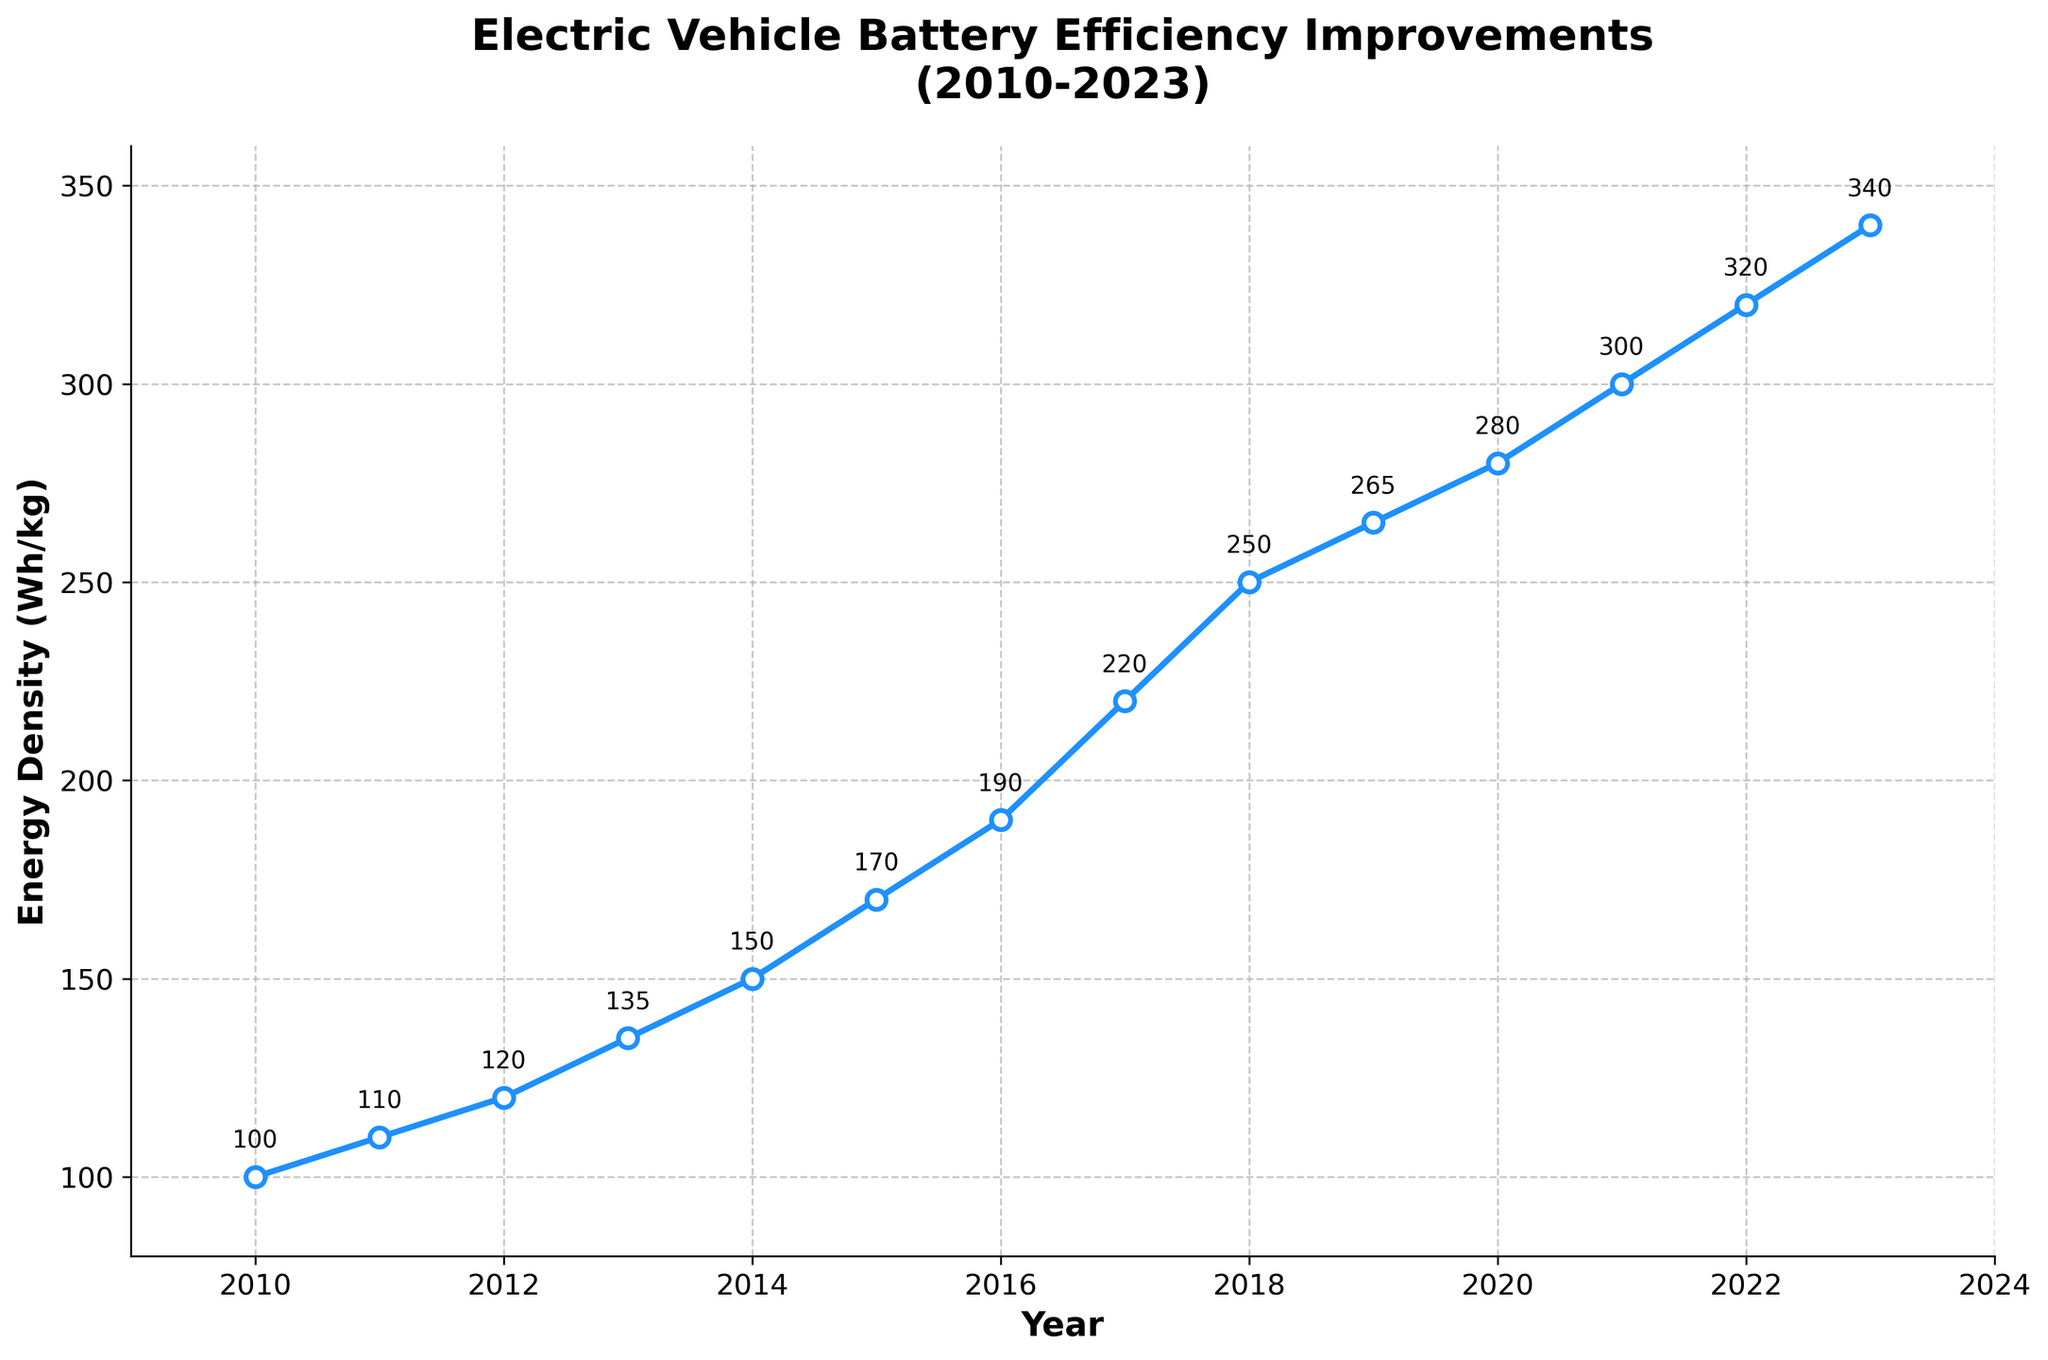What's the energy density in 2015? The figure annotates each point with its corresponding energy density value. For 2015, the annotated value is 170 Wh/kg
Answer: 170 Wh/kg Between which two consecutive years did the energy density see the largest increase? To determine this, look at the differences between consecutive years: 2010-2011 (10), 2011-2012 (10), 2012-2013 (15), 2013-2014 (15), 2014-2015 (20), 2015-2016 (20), 2016-2017 (30), 2017-2018 (30), 2018-2019 (15), 2019-2020 (15), 2020-2021 (20), 2021-2022 (20), 2022-2023 (20). The largest increase, 30, occurs between 2016-2017 and 2017-2018
Answer: 2016-2017 and 2017-2018 What is the average energy density increase per year from 2010 to 2023? First, find the total increase in energy density from 2010 to 2023, which is 340 - 100 = 240 Wh/kg. Then, divide this by the number of years (2023-2010) which is 13. So, 240 / 13 = approximately 18.46 Wh/kg per year
Answer: approximately 18.46 Wh/kg per year In which year does the energy density exceed 200 Wh/kg? From the figure, the energy density exceeds 200 Wh/kg in 2017
Answer: 2017 Which year had exactly 150 Wh/kg energy density? The figure annotates each year's energy density. For 2014, the annotation shows 150 Wh/kg
Answer: 2014 Compare the energy density increase between 2012-2013 and 2013-2014. Which period saw a larger increase? The energy density increased from 120 to 135 between 2012-2013 (15 Wh/kg) and from 135 to 150 between 2013-2014 (15 Wh/kg). Both periods saw the same increase
Answer: Both periods saw the same increase What is the total increase in energy density from 2015 to 2020? The energy density increased from 170 in 2015 to 280 in 2020. Thus, the total increase is 280 - 170 = 110 Wh/kg
Answer: 110 Wh/kg Does the trend line from 2010 to 2023 show a linear or non-linear increase in energy density? Observing the plot, the increments over the years vary, indicating a non-linear increase. Some years show larger jumps than others
Answer: non-linear increase What is the color of the line representing the energy density data in the chart? The line representing the energy density data is blue.
Answer: blue 